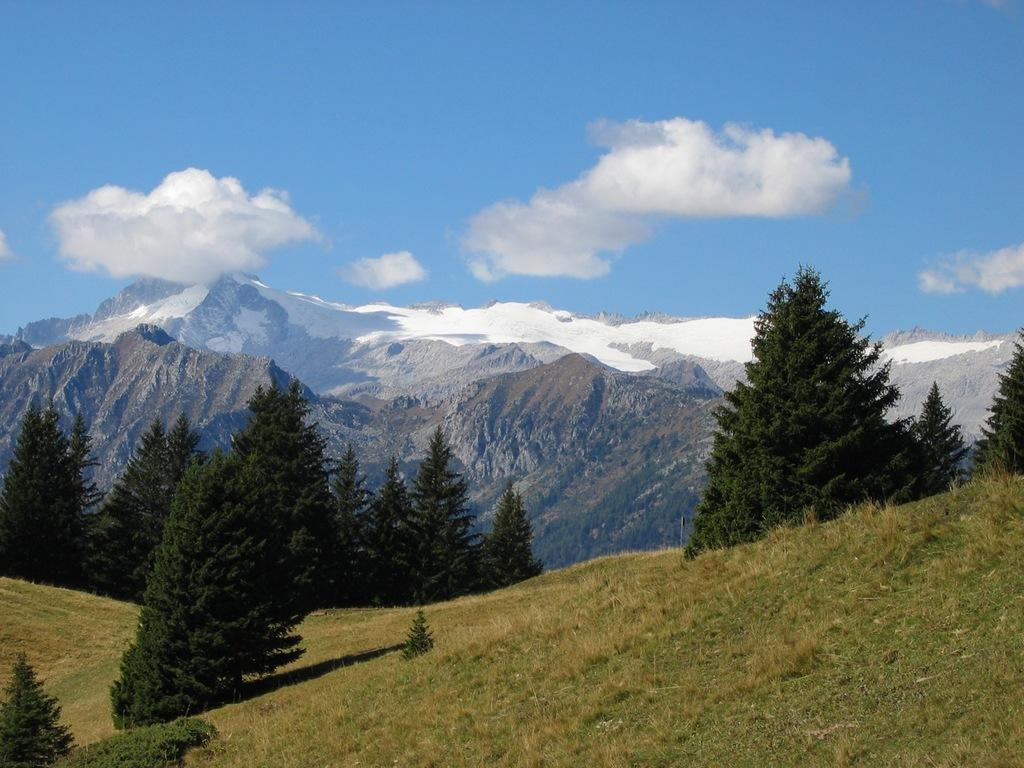What type of vegetation can be seen in the image? There are trees in the image. What geographical features are present in the image? There are hills in the image. What is covering the hills in the image? There is snow on the hills. What type of ground cover can be seen in the image? There is grass on the ground. How would you describe the sky in the image? The sky is blue and cloudy. Can you see a sign indicating the location of the nearest town in the image? There is no sign present in the image. Are there any sisters interacting with each other in the image? There is no indication of any people, let alone sisters, in the image. 